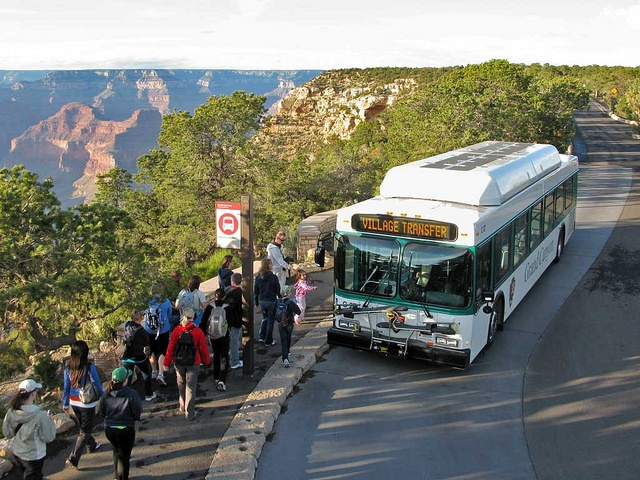Describe the objects in this image and their specific colors. I can see bus in white, black, darkgray, and gray tones, people in white, black, maroon, gray, and brown tones, people in white, black, gray, and darkgray tones, people in white, black, gray, and teal tones, and people in white, gray, and black tones in this image. 